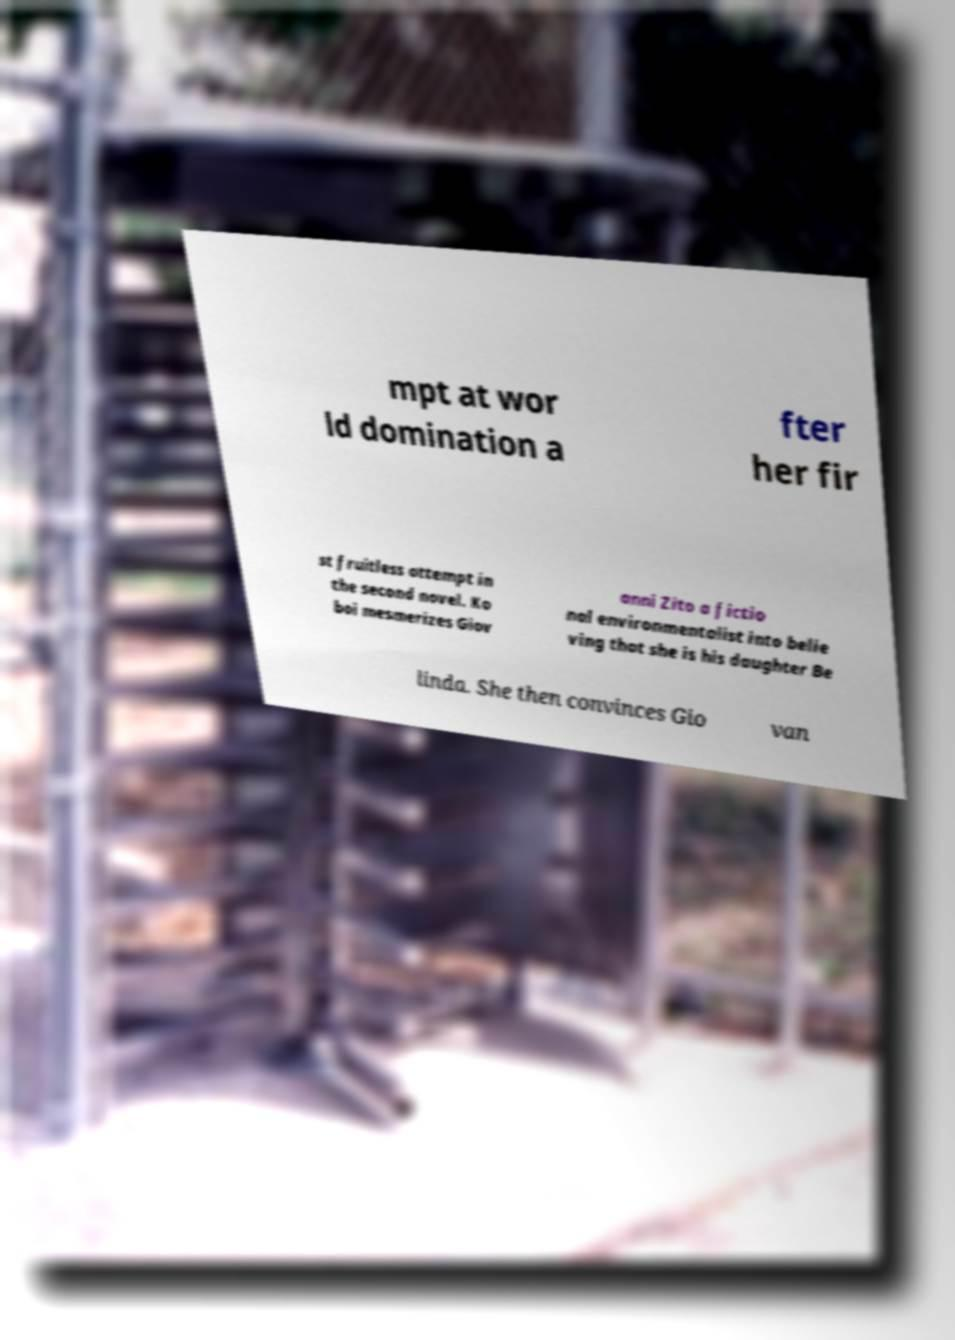What messages or text are displayed in this image? I need them in a readable, typed format. mpt at wor ld domination a fter her fir st fruitless attempt in the second novel. Ko boi mesmerizes Giov anni Zito a fictio nal environmentalist into belie ving that she is his daughter Be linda. She then convinces Gio van 